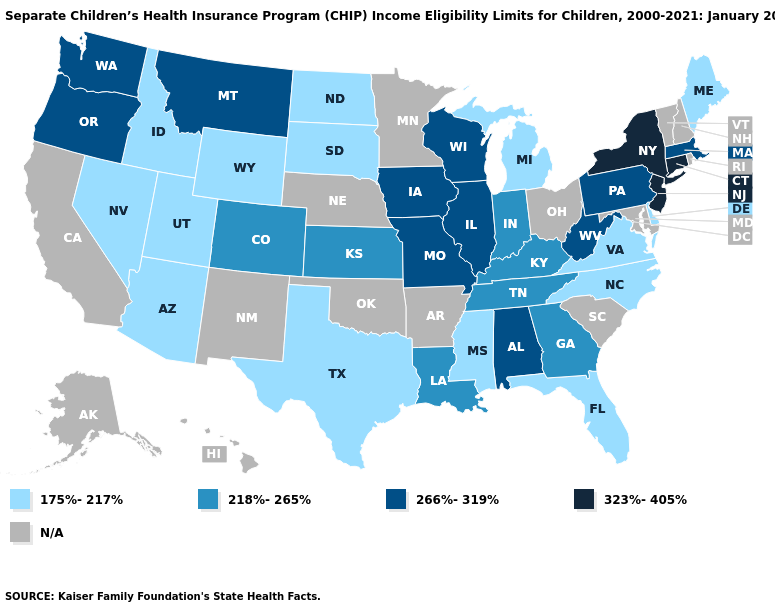What is the value of Alaska?
Concise answer only. N/A. What is the value of Virginia?
Short answer required. 175%-217%. What is the highest value in the South ?
Write a very short answer. 266%-319%. Does Michigan have the highest value in the MidWest?
Write a very short answer. No. Among the states that border Wisconsin , does Michigan have the highest value?
Be succinct. No. Among the states that border Kentucky , which have the highest value?
Short answer required. Illinois, Missouri, West Virginia. Which states hav the highest value in the West?
Give a very brief answer. Montana, Oregon, Washington. Name the states that have a value in the range 266%-319%?
Answer briefly. Alabama, Illinois, Iowa, Massachusetts, Missouri, Montana, Oregon, Pennsylvania, Washington, West Virginia, Wisconsin. Among the states that border Mississippi , does Alabama have the lowest value?
Write a very short answer. No. Name the states that have a value in the range 266%-319%?
Be succinct. Alabama, Illinois, Iowa, Massachusetts, Missouri, Montana, Oregon, Pennsylvania, Washington, West Virginia, Wisconsin. Does South Dakota have the lowest value in the USA?
Concise answer only. Yes. Which states have the lowest value in the MidWest?
Quick response, please. Michigan, North Dakota, South Dakota. Which states have the lowest value in the MidWest?
Keep it brief. Michigan, North Dakota, South Dakota. What is the value of Oregon?
Answer briefly. 266%-319%. 